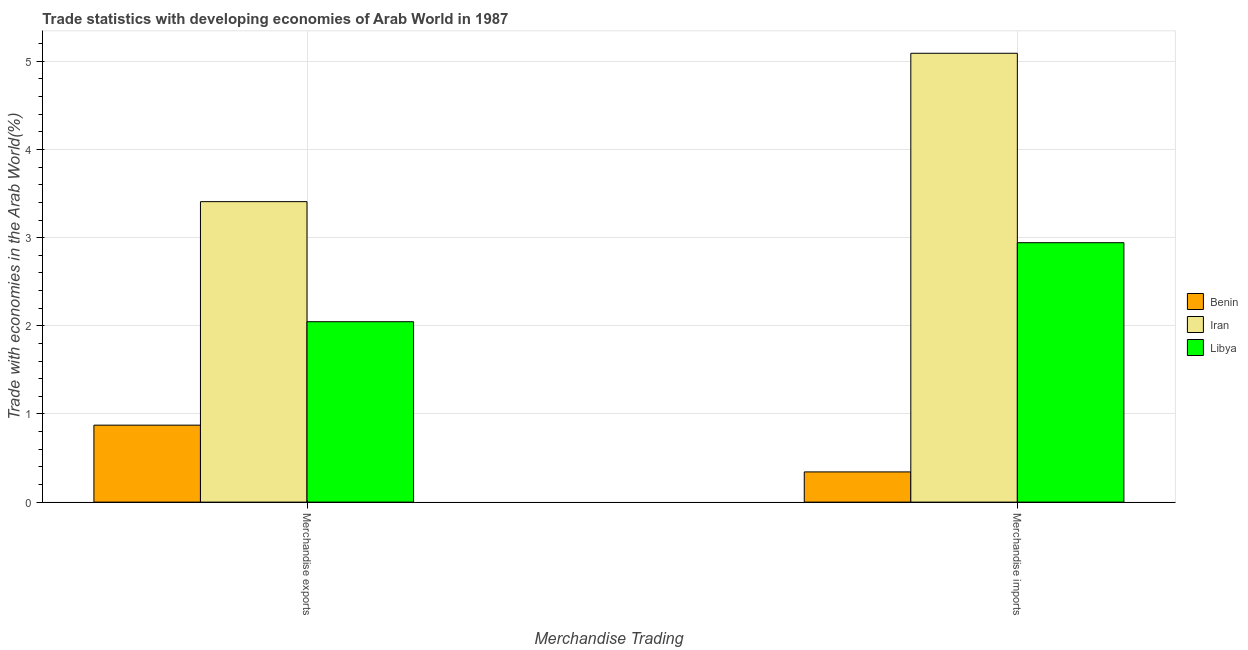How many different coloured bars are there?
Offer a very short reply. 3. How many groups of bars are there?
Your answer should be very brief. 2. What is the merchandise exports in Iran?
Offer a terse response. 3.41. Across all countries, what is the maximum merchandise imports?
Your answer should be very brief. 5.09. Across all countries, what is the minimum merchandise imports?
Give a very brief answer. 0.34. In which country was the merchandise exports maximum?
Give a very brief answer. Iran. In which country was the merchandise imports minimum?
Provide a succinct answer. Benin. What is the total merchandise exports in the graph?
Your response must be concise. 6.33. What is the difference between the merchandise exports in Iran and that in Benin?
Keep it short and to the point. 2.53. What is the difference between the merchandise exports in Benin and the merchandise imports in Libya?
Provide a short and direct response. -2.07. What is the average merchandise imports per country?
Your response must be concise. 2.79. What is the difference between the merchandise imports and merchandise exports in Benin?
Your response must be concise. -0.53. In how many countries, is the merchandise imports greater than 2.6 %?
Offer a very short reply. 2. What is the ratio of the merchandise imports in Benin to that in Iran?
Provide a succinct answer. 0.07. What does the 3rd bar from the left in Merchandise imports represents?
Offer a very short reply. Libya. What does the 1st bar from the right in Merchandise imports represents?
Make the answer very short. Libya. Are all the bars in the graph horizontal?
Your answer should be compact. No. Are the values on the major ticks of Y-axis written in scientific E-notation?
Make the answer very short. No. Does the graph contain grids?
Provide a short and direct response. Yes. Where does the legend appear in the graph?
Make the answer very short. Center right. How are the legend labels stacked?
Keep it short and to the point. Vertical. What is the title of the graph?
Your answer should be very brief. Trade statistics with developing economies of Arab World in 1987. What is the label or title of the X-axis?
Your answer should be compact. Merchandise Trading. What is the label or title of the Y-axis?
Offer a terse response. Trade with economies in the Arab World(%). What is the Trade with economies in the Arab World(%) of Benin in Merchandise exports?
Your answer should be very brief. 0.87. What is the Trade with economies in the Arab World(%) of Iran in Merchandise exports?
Provide a succinct answer. 3.41. What is the Trade with economies in the Arab World(%) of Libya in Merchandise exports?
Your answer should be very brief. 2.05. What is the Trade with economies in the Arab World(%) in Benin in Merchandise imports?
Provide a succinct answer. 0.34. What is the Trade with economies in the Arab World(%) of Iran in Merchandise imports?
Your response must be concise. 5.09. What is the Trade with economies in the Arab World(%) in Libya in Merchandise imports?
Provide a short and direct response. 2.94. Across all Merchandise Trading, what is the maximum Trade with economies in the Arab World(%) of Benin?
Provide a short and direct response. 0.87. Across all Merchandise Trading, what is the maximum Trade with economies in the Arab World(%) of Iran?
Offer a terse response. 5.09. Across all Merchandise Trading, what is the maximum Trade with economies in the Arab World(%) in Libya?
Your answer should be very brief. 2.94. Across all Merchandise Trading, what is the minimum Trade with economies in the Arab World(%) in Benin?
Give a very brief answer. 0.34. Across all Merchandise Trading, what is the minimum Trade with economies in the Arab World(%) of Iran?
Keep it short and to the point. 3.41. Across all Merchandise Trading, what is the minimum Trade with economies in the Arab World(%) of Libya?
Make the answer very short. 2.05. What is the total Trade with economies in the Arab World(%) in Benin in the graph?
Your answer should be compact. 1.22. What is the total Trade with economies in the Arab World(%) of Iran in the graph?
Make the answer very short. 8.5. What is the total Trade with economies in the Arab World(%) in Libya in the graph?
Offer a very short reply. 4.99. What is the difference between the Trade with economies in the Arab World(%) in Benin in Merchandise exports and that in Merchandise imports?
Ensure brevity in your answer.  0.53. What is the difference between the Trade with economies in the Arab World(%) in Iran in Merchandise exports and that in Merchandise imports?
Offer a terse response. -1.68. What is the difference between the Trade with economies in the Arab World(%) in Libya in Merchandise exports and that in Merchandise imports?
Ensure brevity in your answer.  -0.9. What is the difference between the Trade with economies in the Arab World(%) of Benin in Merchandise exports and the Trade with economies in the Arab World(%) of Iran in Merchandise imports?
Offer a very short reply. -4.22. What is the difference between the Trade with economies in the Arab World(%) of Benin in Merchandise exports and the Trade with economies in the Arab World(%) of Libya in Merchandise imports?
Provide a succinct answer. -2.07. What is the difference between the Trade with economies in the Arab World(%) of Iran in Merchandise exports and the Trade with economies in the Arab World(%) of Libya in Merchandise imports?
Provide a short and direct response. 0.47. What is the average Trade with economies in the Arab World(%) of Benin per Merchandise Trading?
Ensure brevity in your answer.  0.61. What is the average Trade with economies in the Arab World(%) of Iran per Merchandise Trading?
Provide a short and direct response. 4.25. What is the average Trade with economies in the Arab World(%) of Libya per Merchandise Trading?
Your answer should be compact. 2.49. What is the difference between the Trade with economies in the Arab World(%) in Benin and Trade with economies in the Arab World(%) in Iran in Merchandise exports?
Offer a terse response. -2.54. What is the difference between the Trade with economies in the Arab World(%) of Benin and Trade with economies in the Arab World(%) of Libya in Merchandise exports?
Your answer should be compact. -1.17. What is the difference between the Trade with economies in the Arab World(%) of Iran and Trade with economies in the Arab World(%) of Libya in Merchandise exports?
Keep it short and to the point. 1.36. What is the difference between the Trade with economies in the Arab World(%) in Benin and Trade with economies in the Arab World(%) in Iran in Merchandise imports?
Make the answer very short. -4.75. What is the difference between the Trade with economies in the Arab World(%) of Iran and Trade with economies in the Arab World(%) of Libya in Merchandise imports?
Ensure brevity in your answer.  2.15. What is the ratio of the Trade with economies in the Arab World(%) in Benin in Merchandise exports to that in Merchandise imports?
Make the answer very short. 2.55. What is the ratio of the Trade with economies in the Arab World(%) of Iran in Merchandise exports to that in Merchandise imports?
Provide a succinct answer. 0.67. What is the ratio of the Trade with economies in the Arab World(%) of Libya in Merchandise exports to that in Merchandise imports?
Give a very brief answer. 0.7. What is the difference between the highest and the second highest Trade with economies in the Arab World(%) in Benin?
Keep it short and to the point. 0.53. What is the difference between the highest and the second highest Trade with economies in the Arab World(%) in Iran?
Make the answer very short. 1.68. What is the difference between the highest and the second highest Trade with economies in the Arab World(%) in Libya?
Your response must be concise. 0.9. What is the difference between the highest and the lowest Trade with economies in the Arab World(%) in Benin?
Your response must be concise. 0.53. What is the difference between the highest and the lowest Trade with economies in the Arab World(%) in Iran?
Keep it short and to the point. 1.68. What is the difference between the highest and the lowest Trade with economies in the Arab World(%) in Libya?
Provide a short and direct response. 0.9. 